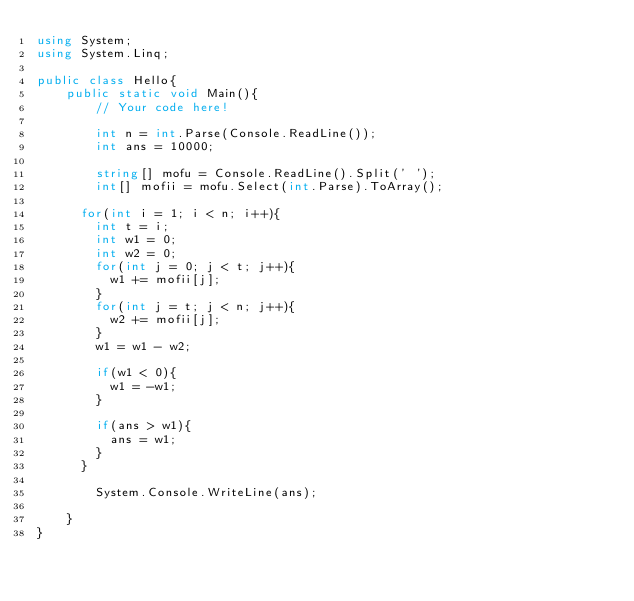<code> <loc_0><loc_0><loc_500><loc_500><_C#_>using System;
using System.Linq;

public class Hello{
    public static void Main(){
        // Your code here!
        
        int n = int.Parse(Console.ReadLine());
        int ans = 10000; 
      
        string[] mofu = Console.ReadLine().Split(' ');
        int[] mofii = mofu.Select(int.Parse).ToArray();

      for(int i = 1; i < n; i++){
        int t = i;
        int w1 = 0;
        int w2 = 0;
        for(int j = 0; j < t; j++){
          w1 += mofii[j];
        }
        for(int j = t; j < n; j++){
          w2 += mofii[j];
        }
        w1 = w1 - w2;
        
        if(w1 < 0){
          w1 = -w1;
        }
        
        if(ans > w1){
          ans = w1;
        }
      }
      
        System.Console.WriteLine(ans);
      
    }
}
</code> 